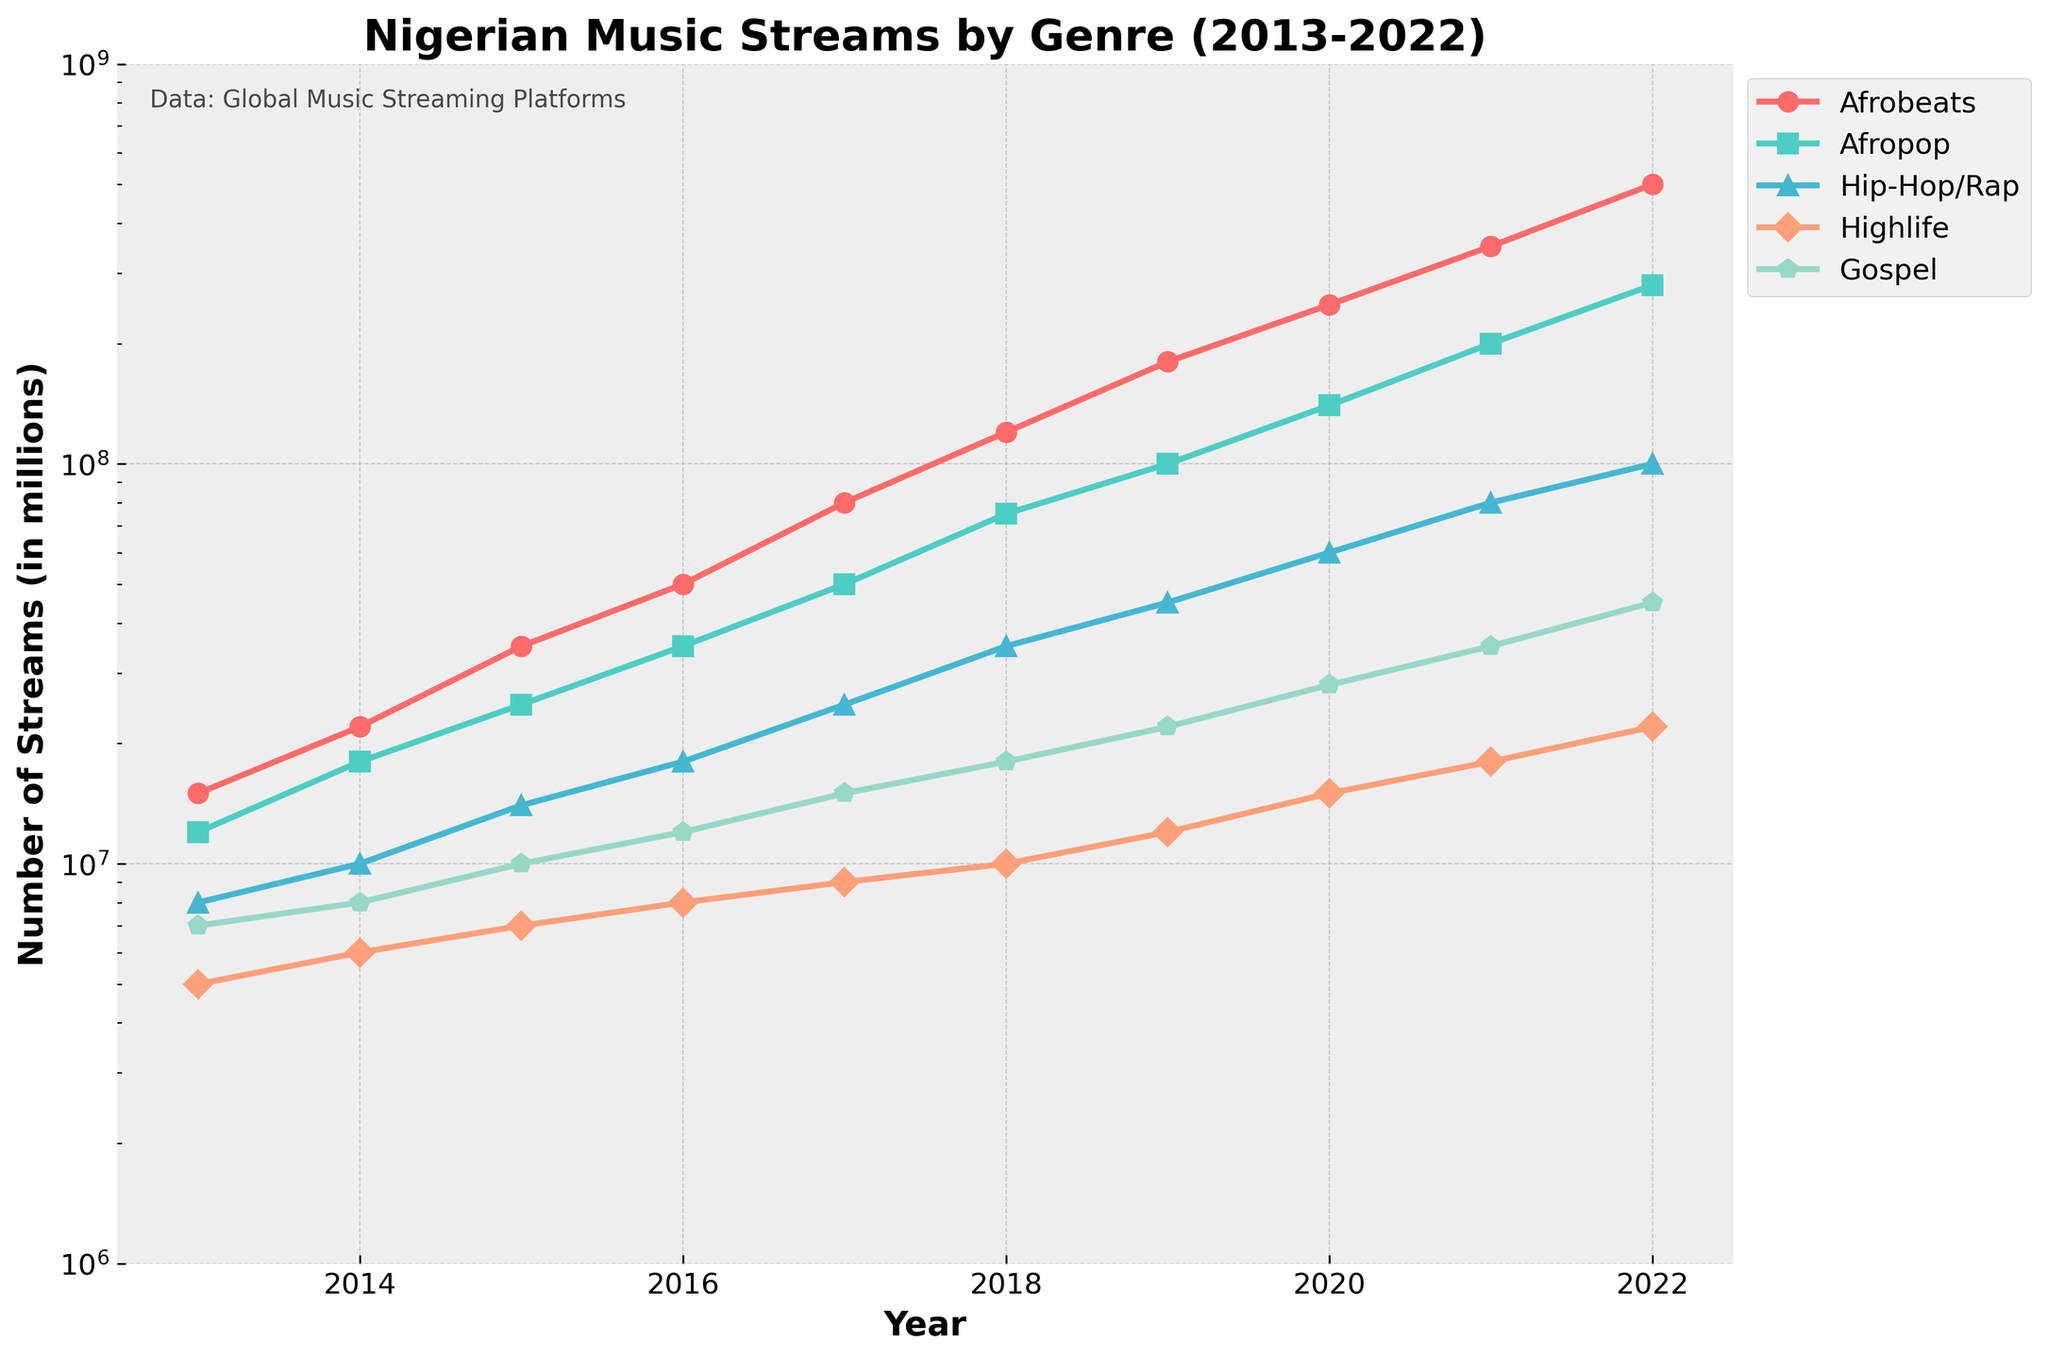What genre had the highest number of streams in 2022? By observing the endpoint of each line on the chart, Afrobeats has the highest number of streams in 2022.
Answer: Afrobeats How did the streams for Afropop change from 2017 to 2022? The streams for Afropop in 2017 were 50,000,000, and in 2022 they were 280,000,000. The change is 280,000,000 - 50,000,000 = 230,000,000.
Answer: Increased by 230,000,000 Which genre had the lowest number of streams in 2020 and what was the value? By locating the 2020 data point for each genre, Highlife had the lowest number of streams with 15,000,000 streams.
Answer: Highlife, 15,000,000 Compare the streams of Hip-Hop/Rap and Gospel in 2021. Which one was higher and by how much? In 2021, Hip-Hop/Rap had 80,000,000 streams, and Gospel had 35,000,000 streams. The difference is 80,000,000 - 35,000,000 = 45,000,000.
Answer: Hip-Hop/Rap, 45,000,000 Which genre experienced the fastest growth in streams between 2013 and 2022? By examining the steepness of the lines, Afrobeats shows the fastest growth. It increases from 15,000,000 streams in 2013 to 500,000,000 in 2022.
Answer: Afrobeats What is the average number of streams for Afrobeats across the entire decade? Summing the values for each year and dividing by 10, we get (15,000,000 + 22,000,000 + 35,000,000 + 50,000,000 + 80,000,000 + 120,000,000 + 180,000,000 + 250,000,000 + 350,000,000 + 500,000,000)/10 = 160,200,000.
Answer: 160,200,000 Which genre has the steepest increase in streams between any consecutive years in the period? The steepest increase can be observed for Afrobeats between 2021 and 2022, where it rises from 350,000,000 to 500,000,000 streams, an increase of 150,000,000.
Answer: Afrobeats How do the 2022 streams for Highlife compare to those in 2013? Highlife had 5,000,000 streams in 2013 and 22,000,000 streams in 2022, an increase of 17,000,000.
Answer: Increased by 17,000,000 Rank the genres based on their stream numbers in 2022 from highest to lowest. For 2022, the streams are: Afrobeats (500,000,000), Afropop (280,000,000), Hip-Hop/Rap (100,000,000), Gospel (45,000,000), Highlife (22,000,000). So, the rank is: Afrobeats > Afropop > Hip-Hop/Rap > Gospel > Highlife.
Answer: Afrobeats, Afropop, Hip-Hop/Rap, Gospel, Highlife 